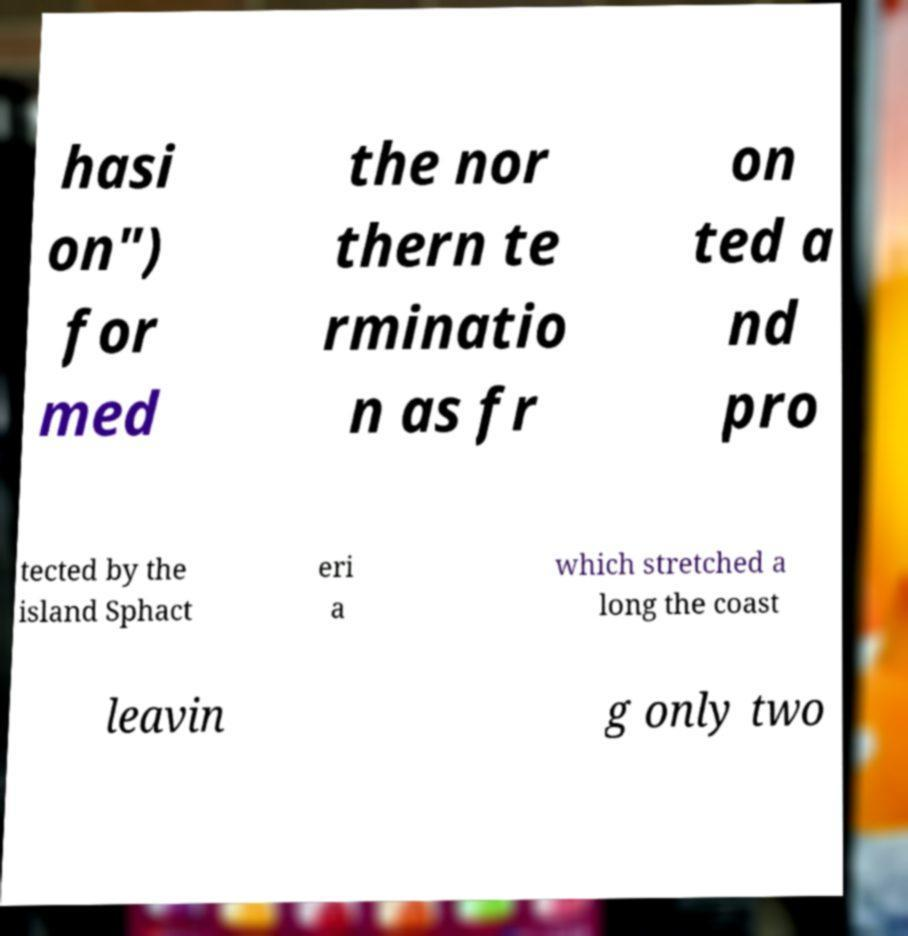For documentation purposes, I need the text within this image transcribed. Could you provide that? hasi on") for med the nor thern te rminatio n as fr on ted a nd pro tected by the island Sphact eri a which stretched a long the coast leavin g only two 